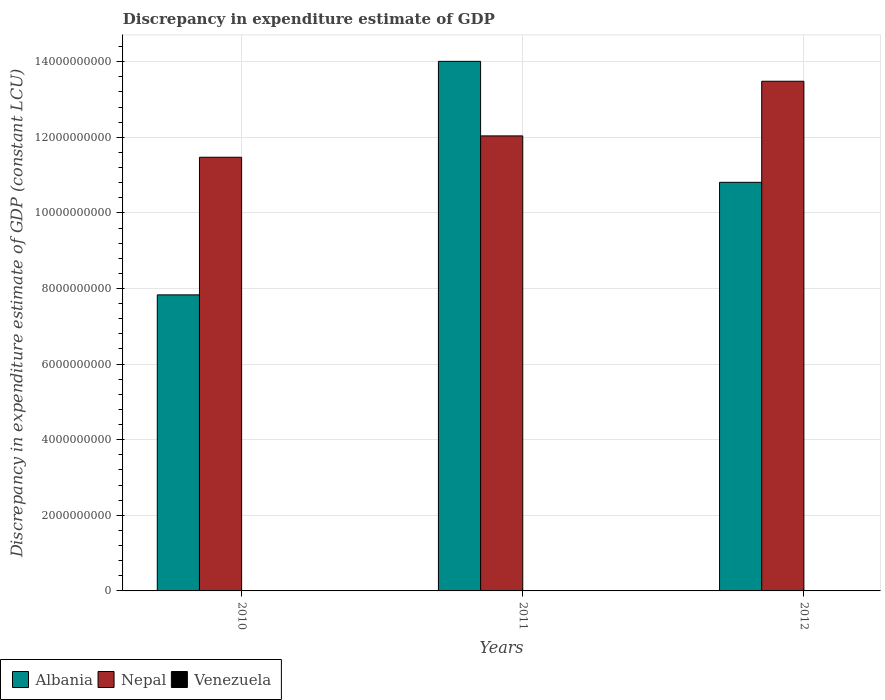How many bars are there on the 2nd tick from the left?
Your response must be concise. 2. How many bars are there on the 1st tick from the right?
Provide a succinct answer. 2. What is the discrepancy in expenditure estimate of GDP in Venezuela in 2010?
Offer a very short reply. 4.90e+05. Across all years, what is the maximum discrepancy in expenditure estimate of GDP in Albania?
Give a very brief answer. 1.40e+1. Across all years, what is the minimum discrepancy in expenditure estimate of GDP in Nepal?
Your answer should be very brief. 1.15e+1. What is the total discrepancy in expenditure estimate of GDP in Albania in the graph?
Offer a very short reply. 3.27e+1. What is the difference between the discrepancy in expenditure estimate of GDP in Albania in 2010 and that in 2011?
Offer a very short reply. -6.18e+09. What is the difference between the discrepancy in expenditure estimate of GDP in Nepal in 2010 and the discrepancy in expenditure estimate of GDP in Albania in 2012?
Your answer should be compact. 6.63e+08. What is the average discrepancy in expenditure estimate of GDP in Albania per year?
Offer a terse response. 1.09e+1. In the year 2010, what is the difference between the discrepancy in expenditure estimate of GDP in Venezuela and discrepancy in expenditure estimate of GDP in Albania?
Offer a very short reply. -7.83e+09. In how many years, is the discrepancy in expenditure estimate of GDP in Venezuela greater than 6000000000 LCU?
Ensure brevity in your answer.  0. What is the ratio of the discrepancy in expenditure estimate of GDP in Nepal in 2010 to that in 2012?
Make the answer very short. 0.85. Is the discrepancy in expenditure estimate of GDP in Albania in 2011 less than that in 2012?
Offer a terse response. No. What is the difference between the highest and the second highest discrepancy in expenditure estimate of GDP in Albania?
Keep it short and to the point. 3.20e+09. What is the difference between the highest and the lowest discrepancy in expenditure estimate of GDP in Venezuela?
Make the answer very short. 4.90e+05. Is the sum of the discrepancy in expenditure estimate of GDP in Nepal in 2011 and 2012 greater than the maximum discrepancy in expenditure estimate of GDP in Albania across all years?
Keep it short and to the point. Yes. Are all the bars in the graph horizontal?
Give a very brief answer. No. Are the values on the major ticks of Y-axis written in scientific E-notation?
Offer a very short reply. No. Does the graph contain any zero values?
Your answer should be compact. Yes. Where does the legend appear in the graph?
Ensure brevity in your answer.  Bottom left. How many legend labels are there?
Offer a terse response. 3. What is the title of the graph?
Give a very brief answer. Discrepancy in expenditure estimate of GDP. What is the label or title of the X-axis?
Provide a short and direct response. Years. What is the label or title of the Y-axis?
Provide a short and direct response. Discrepancy in expenditure estimate of GDP (constant LCU). What is the Discrepancy in expenditure estimate of GDP (constant LCU) in Albania in 2010?
Make the answer very short. 7.83e+09. What is the Discrepancy in expenditure estimate of GDP (constant LCU) in Nepal in 2010?
Offer a terse response. 1.15e+1. What is the Discrepancy in expenditure estimate of GDP (constant LCU) of Albania in 2011?
Offer a terse response. 1.40e+1. What is the Discrepancy in expenditure estimate of GDP (constant LCU) of Nepal in 2011?
Give a very brief answer. 1.20e+1. What is the Discrepancy in expenditure estimate of GDP (constant LCU) in Venezuela in 2011?
Provide a succinct answer. 0. What is the Discrepancy in expenditure estimate of GDP (constant LCU) in Albania in 2012?
Your answer should be compact. 1.08e+1. What is the Discrepancy in expenditure estimate of GDP (constant LCU) in Nepal in 2012?
Offer a very short reply. 1.35e+1. Across all years, what is the maximum Discrepancy in expenditure estimate of GDP (constant LCU) of Albania?
Give a very brief answer. 1.40e+1. Across all years, what is the maximum Discrepancy in expenditure estimate of GDP (constant LCU) in Nepal?
Offer a terse response. 1.35e+1. Across all years, what is the minimum Discrepancy in expenditure estimate of GDP (constant LCU) in Albania?
Provide a short and direct response. 7.83e+09. Across all years, what is the minimum Discrepancy in expenditure estimate of GDP (constant LCU) in Nepal?
Make the answer very short. 1.15e+1. What is the total Discrepancy in expenditure estimate of GDP (constant LCU) in Albania in the graph?
Provide a short and direct response. 3.27e+1. What is the total Discrepancy in expenditure estimate of GDP (constant LCU) of Nepal in the graph?
Provide a short and direct response. 3.70e+1. What is the total Discrepancy in expenditure estimate of GDP (constant LCU) of Venezuela in the graph?
Your answer should be very brief. 4.90e+05. What is the difference between the Discrepancy in expenditure estimate of GDP (constant LCU) of Albania in 2010 and that in 2011?
Give a very brief answer. -6.18e+09. What is the difference between the Discrepancy in expenditure estimate of GDP (constant LCU) of Nepal in 2010 and that in 2011?
Ensure brevity in your answer.  -5.65e+08. What is the difference between the Discrepancy in expenditure estimate of GDP (constant LCU) of Albania in 2010 and that in 2012?
Your response must be concise. -2.98e+09. What is the difference between the Discrepancy in expenditure estimate of GDP (constant LCU) of Nepal in 2010 and that in 2012?
Provide a short and direct response. -2.01e+09. What is the difference between the Discrepancy in expenditure estimate of GDP (constant LCU) of Albania in 2011 and that in 2012?
Your answer should be very brief. 3.20e+09. What is the difference between the Discrepancy in expenditure estimate of GDP (constant LCU) in Nepal in 2011 and that in 2012?
Offer a very short reply. -1.45e+09. What is the difference between the Discrepancy in expenditure estimate of GDP (constant LCU) in Albania in 2010 and the Discrepancy in expenditure estimate of GDP (constant LCU) in Nepal in 2011?
Your answer should be compact. -4.21e+09. What is the difference between the Discrepancy in expenditure estimate of GDP (constant LCU) in Albania in 2010 and the Discrepancy in expenditure estimate of GDP (constant LCU) in Nepal in 2012?
Keep it short and to the point. -5.65e+09. What is the difference between the Discrepancy in expenditure estimate of GDP (constant LCU) of Albania in 2011 and the Discrepancy in expenditure estimate of GDP (constant LCU) of Nepal in 2012?
Your answer should be compact. 5.26e+08. What is the average Discrepancy in expenditure estimate of GDP (constant LCU) in Albania per year?
Your answer should be very brief. 1.09e+1. What is the average Discrepancy in expenditure estimate of GDP (constant LCU) of Nepal per year?
Your answer should be compact. 1.23e+1. What is the average Discrepancy in expenditure estimate of GDP (constant LCU) of Venezuela per year?
Make the answer very short. 1.63e+05. In the year 2010, what is the difference between the Discrepancy in expenditure estimate of GDP (constant LCU) of Albania and Discrepancy in expenditure estimate of GDP (constant LCU) of Nepal?
Make the answer very short. -3.64e+09. In the year 2010, what is the difference between the Discrepancy in expenditure estimate of GDP (constant LCU) in Albania and Discrepancy in expenditure estimate of GDP (constant LCU) in Venezuela?
Provide a short and direct response. 7.83e+09. In the year 2010, what is the difference between the Discrepancy in expenditure estimate of GDP (constant LCU) of Nepal and Discrepancy in expenditure estimate of GDP (constant LCU) of Venezuela?
Ensure brevity in your answer.  1.15e+1. In the year 2011, what is the difference between the Discrepancy in expenditure estimate of GDP (constant LCU) of Albania and Discrepancy in expenditure estimate of GDP (constant LCU) of Nepal?
Offer a terse response. 1.97e+09. In the year 2012, what is the difference between the Discrepancy in expenditure estimate of GDP (constant LCU) of Albania and Discrepancy in expenditure estimate of GDP (constant LCU) of Nepal?
Provide a succinct answer. -2.67e+09. What is the ratio of the Discrepancy in expenditure estimate of GDP (constant LCU) of Albania in 2010 to that in 2011?
Give a very brief answer. 0.56. What is the ratio of the Discrepancy in expenditure estimate of GDP (constant LCU) of Nepal in 2010 to that in 2011?
Your answer should be compact. 0.95. What is the ratio of the Discrepancy in expenditure estimate of GDP (constant LCU) in Albania in 2010 to that in 2012?
Provide a short and direct response. 0.72. What is the ratio of the Discrepancy in expenditure estimate of GDP (constant LCU) of Nepal in 2010 to that in 2012?
Offer a very short reply. 0.85. What is the ratio of the Discrepancy in expenditure estimate of GDP (constant LCU) of Albania in 2011 to that in 2012?
Ensure brevity in your answer.  1.3. What is the ratio of the Discrepancy in expenditure estimate of GDP (constant LCU) of Nepal in 2011 to that in 2012?
Your response must be concise. 0.89. What is the difference between the highest and the second highest Discrepancy in expenditure estimate of GDP (constant LCU) in Albania?
Give a very brief answer. 3.20e+09. What is the difference between the highest and the second highest Discrepancy in expenditure estimate of GDP (constant LCU) of Nepal?
Provide a short and direct response. 1.45e+09. What is the difference between the highest and the lowest Discrepancy in expenditure estimate of GDP (constant LCU) of Albania?
Make the answer very short. 6.18e+09. What is the difference between the highest and the lowest Discrepancy in expenditure estimate of GDP (constant LCU) of Nepal?
Provide a short and direct response. 2.01e+09. What is the difference between the highest and the lowest Discrepancy in expenditure estimate of GDP (constant LCU) of Venezuela?
Your answer should be very brief. 4.90e+05. 